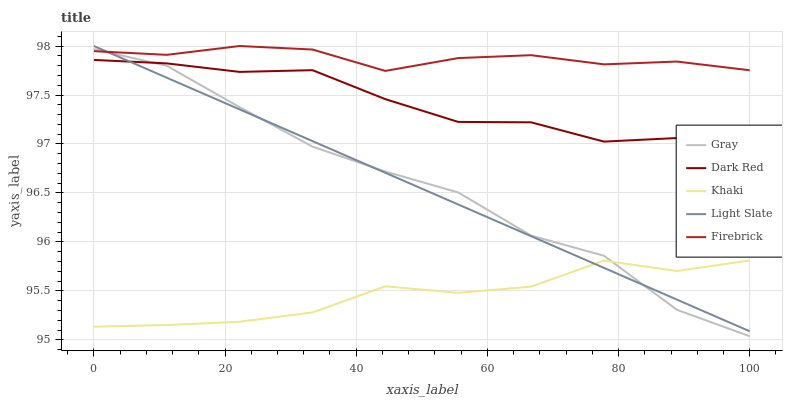Does Khaki have the minimum area under the curve?
Answer yes or no. Yes. Does Firebrick have the maximum area under the curve?
Answer yes or no. Yes. Does Gray have the minimum area under the curve?
Answer yes or no. No. Does Gray have the maximum area under the curve?
Answer yes or no. No. Is Light Slate the smoothest?
Answer yes or no. Yes. Is Gray the roughest?
Answer yes or no. Yes. Is Firebrick the smoothest?
Answer yes or no. No. Is Firebrick the roughest?
Answer yes or no. No. Does Gray have the lowest value?
Answer yes or no. Yes. Does Firebrick have the lowest value?
Answer yes or no. No. Does Firebrick have the highest value?
Answer yes or no. Yes. Does Gray have the highest value?
Answer yes or no. No. Is Dark Red less than Firebrick?
Answer yes or no. Yes. Is Dark Red greater than Khaki?
Answer yes or no. Yes. Does Light Slate intersect Khaki?
Answer yes or no. Yes. Is Light Slate less than Khaki?
Answer yes or no. No. Is Light Slate greater than Khaki?
Answer yes or no. No. Does Dark Red intersect Firebrick?
Answer yes or no. No. 